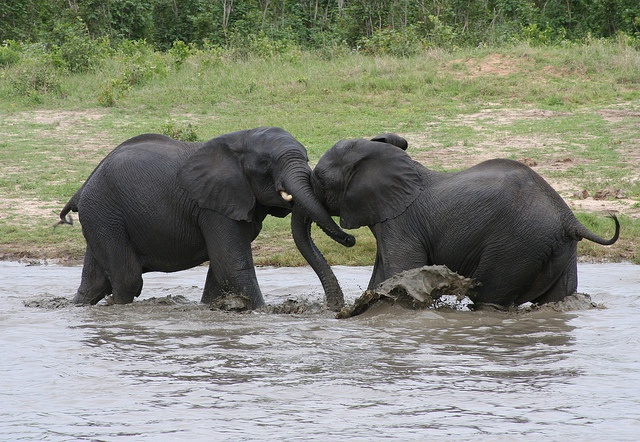Describe the objects in this image and their specific colors. I can see elephant in darkgreen, black, gray, and olive tones and elephant in darkgreen, black, gray, and darkgray tones in this image. 